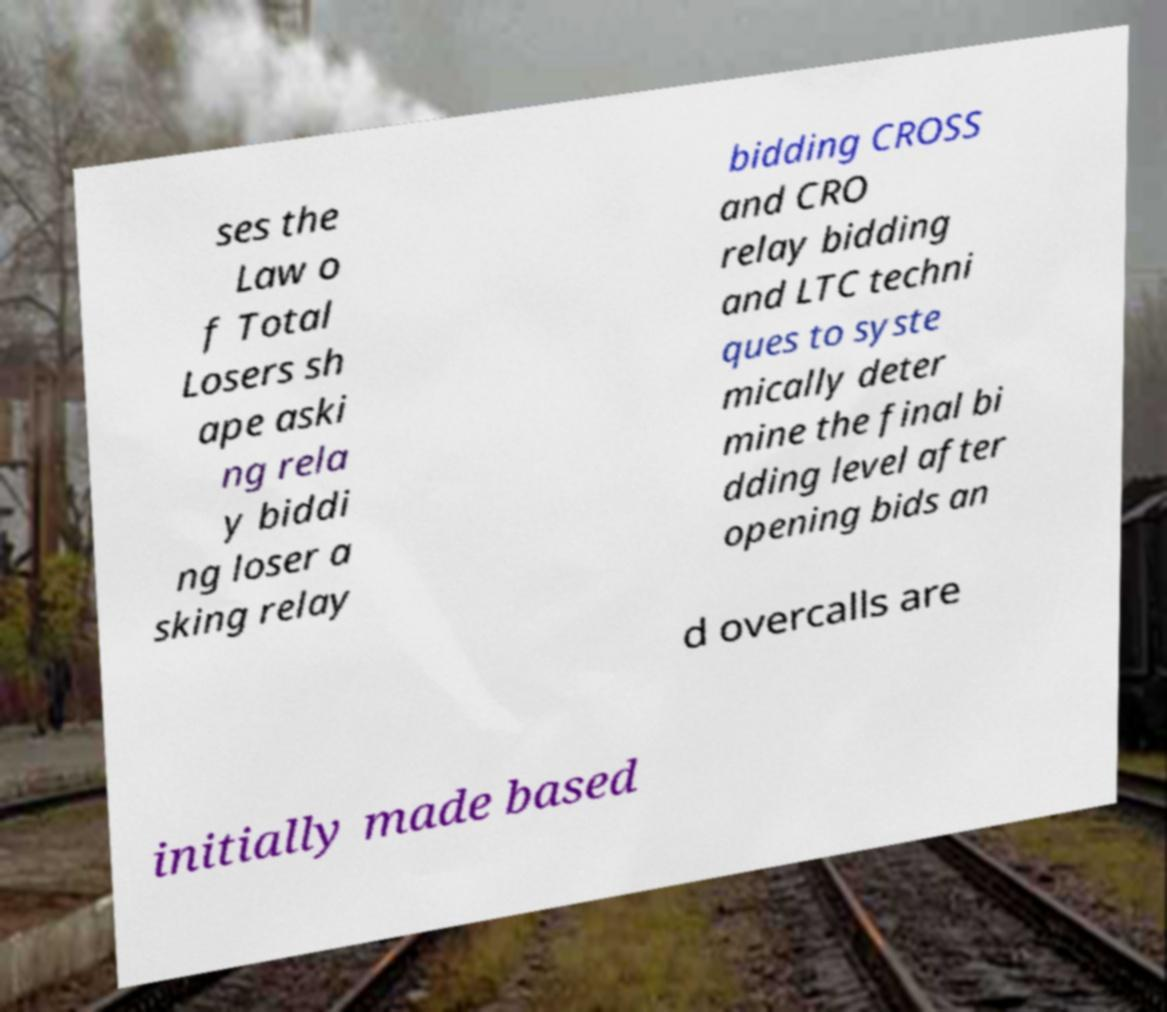What messages or text are displayed in this image? I need them in a readable, typed format. ses the Law o f Total Losers sh ape aski ng rela y biddi ng loser a sking relay bidding CROSS and CRO relay bidding and LTC techni ques to syste mically deter mine the final bi dding level after opening bids an d overcalls are initially made based 